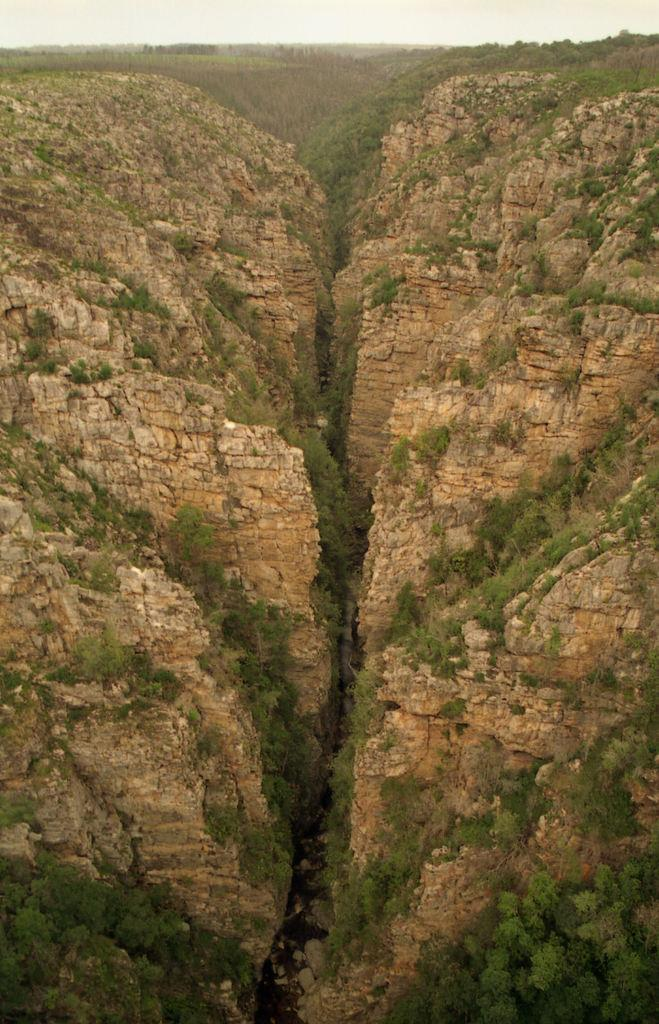What type of geographical feature can be seen in the image? There are mountains in the image. What can be found between the mountains in the image? There is a valley in the image. What type of vegetation is present in the image? There are trees in the image. What type of current can be seen flowing through the valley in the image? There is no current visible in the image; it is a still landscape featuring mountains, a valley, and trees. 